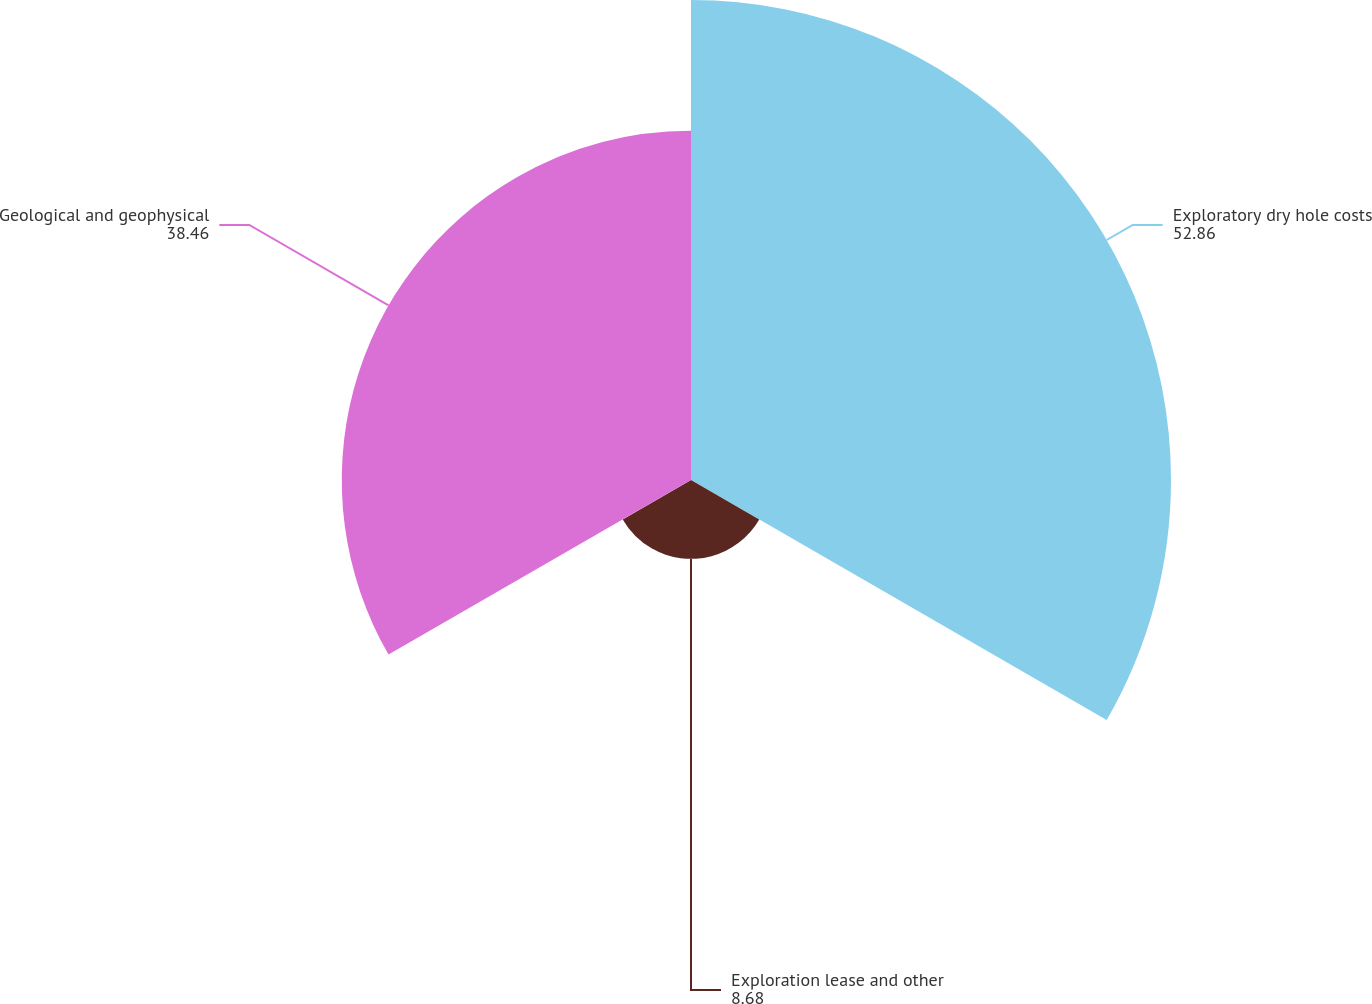Convert chart. <chart><loc_0><loc_0><loc_500><loc_500><pie_chart><fcel>Exploratory dry hole costs<fcel>Exploration lease and other<fcel>Geological and geophysical<nl><fcel>52.86%<fcel>8.68%<fcel>38.46%<nl></chart> 